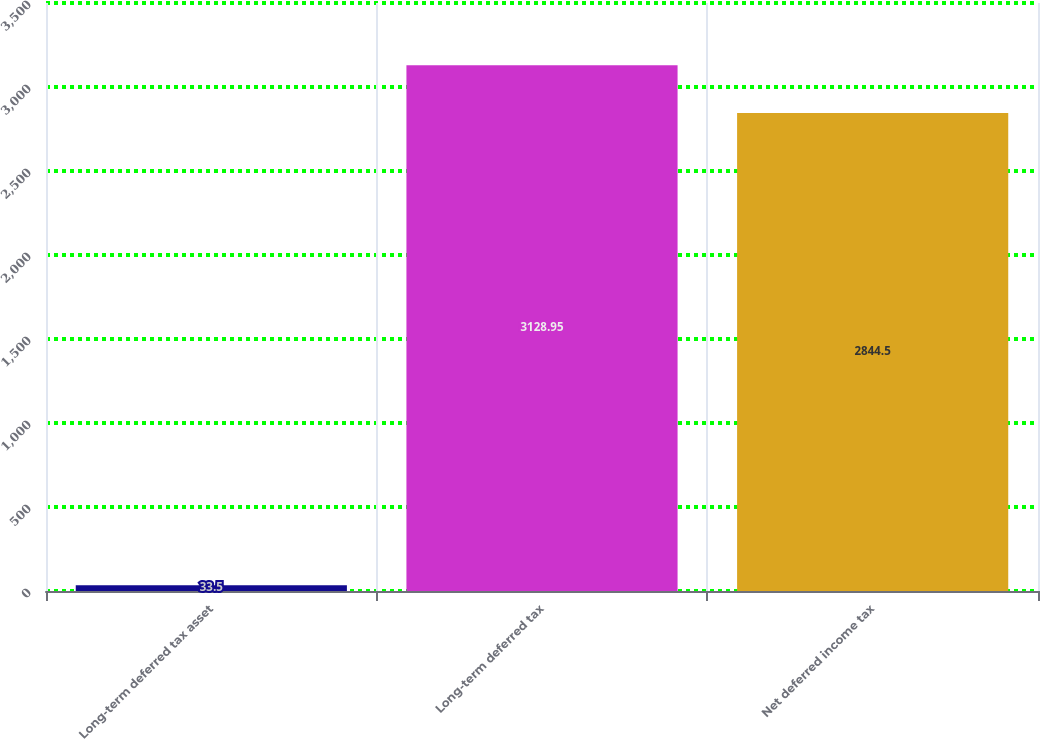Convert chart to OTSL. <chart><loc_0><loc_0><loc_500><loc_500><bar_chart><fcel>Long-term deferred tax asset<fcel>Long-term deferred tax<fcel>Net deferred income tax<nl><fcel>33.5<fcel>3128.95<fcel>2844.5<nl></chart> 